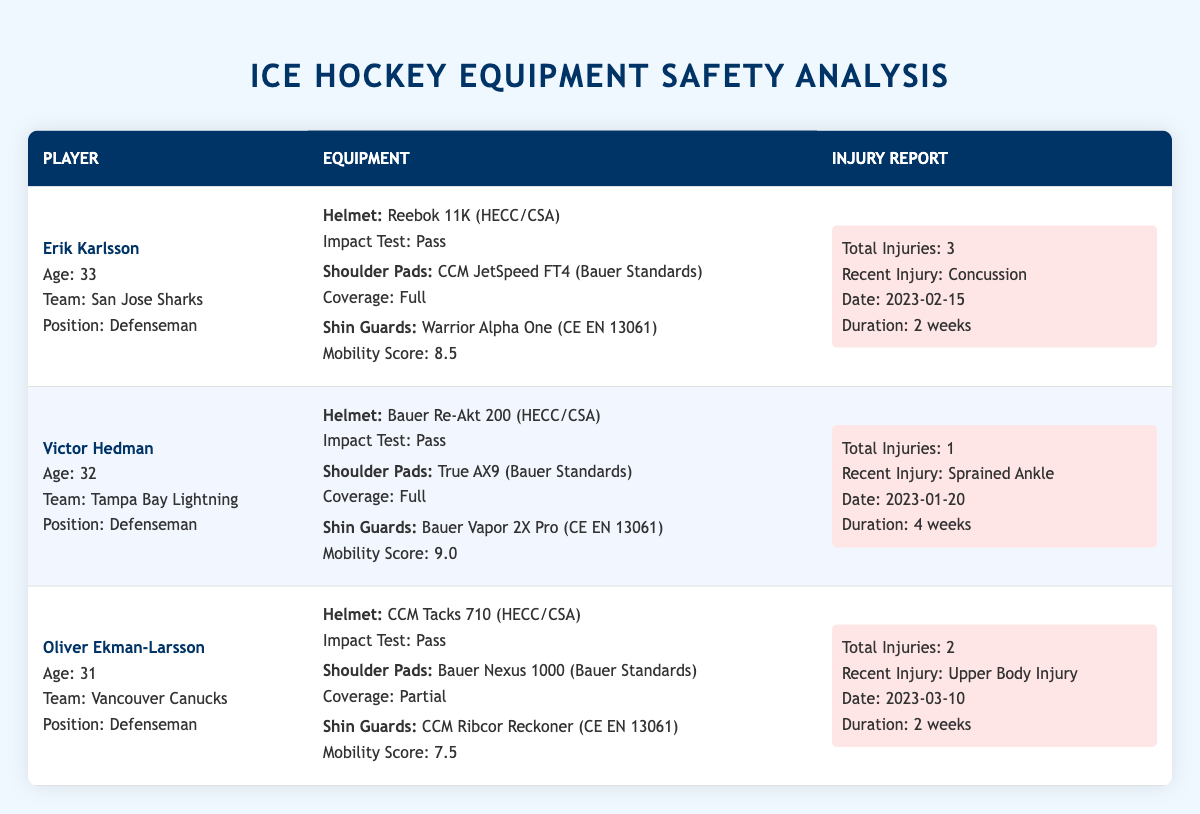What is the total number of injuries for Erik Karlsson? The total injuries for Erik Karlsson are presented in the injury report section of the table. It states that he has a total of 3 injuries.
Answer: 3 What model of helmet does Victor Hedman use? The equipment section for Victor Hedman shows that his helmet model is Bauer Re-Akt 200.
Answer: Bauer Re-Akt 200 Is the shoulder pad coverage for Oliver Ekman-Larsson full? The equipment section indicates that Oliver Ekman-Larsson's shoulder pads (Bauer Nexus 1000) have a coverage area of "Partial," which confirms that it is not full.
Answer: No What is the mobility score for shin guards used by Erik Karlsson? In the equipment section for Erik Karlsson, the shin guards are Warrior Alpha One with a mobility score listed as 8.5.
Answer: 8.5 Which defenseman has the most total injuries listed in this table? The total injuries are summarized in the injury report for each player. Erik Karlsson has 3 injuries, Victor Hedman has 1, and Oliver Ekman-Larsson has 2. Thus, Erik Karlsson has the most injuries.
Answer: Erik Karlsson What is the difference in mobility scores between the shin guards of Victor Hedman and Oliver Ekman-Larsson? The mobility score for Victor Hedman’s shin guards is 9.0 and for Oliver Ekman-Larsson's shin guards is 7.5. To find the difference: 9.0 - 7.5 = 1.5.
Answer: 1.5 Did any player recently sustain a concussion? The injury report shows that Erik Karlsson sustained a concussion recently on 2023-02-15. Therefore, the answer is yes.
Answer: Yes What is the average number of total injuries across the three defensemen? The total injuries are: Erik Karlsson (3), Victor Hedman (1), and Oliver Ekman-Larsson (2). To find the average: (3 + 1 + 2) / 3 = 2. Therefore, the average is 2.
Answer: 2 Which player's equipment includes shoulder pads with partial coverage? The table indicates that Oliver Ekman-Larsson has shoulder pads (Bauer Nexus 1000) with partial coverage.
Answer: Oliver Ekman-Larsson 